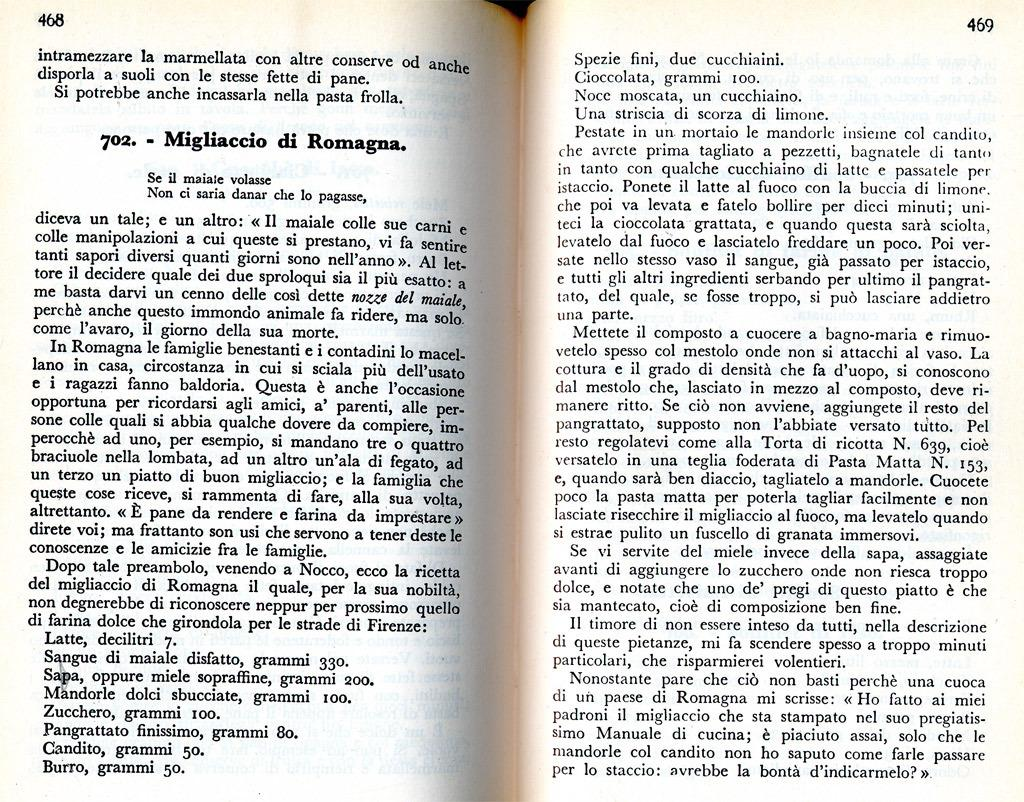<image>
Give a short and clear explanation of the subsequent image. a book opened to pages 468 and 469 